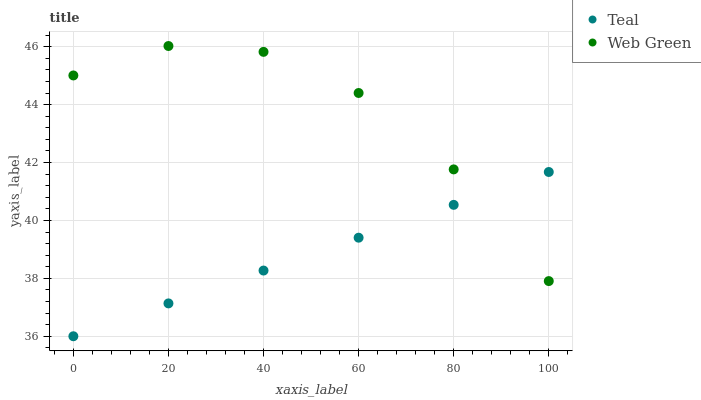Does Teal have the minimum area under the curve?
Answer yes or no. Yes. Does Web Green have the maximum area under the curve?
Answer yes or no. Yes. Does Teal have the maximum area under the curve?
Answer yes or no. No. Is Teal the smoothest?
Answer yes or no. Yes. Is Web Green the roughest?
Answer yes or no. Yes. Is Teal the roughest?
Answer yes or no. No. Does Teal have the lowest value?
Answer yes or no. Yes. Does Web Green have the highest value?
Answer yes or no. Yes. Does Teal have the highest value?
Answer yes or no. No. Does Web Green intersect Teal?
Answer yes or no. Yes. Is Web Green less than Teal?
Answer yes or no. No. Is Web Green greater than Teal?
Answer yes or no. No. 